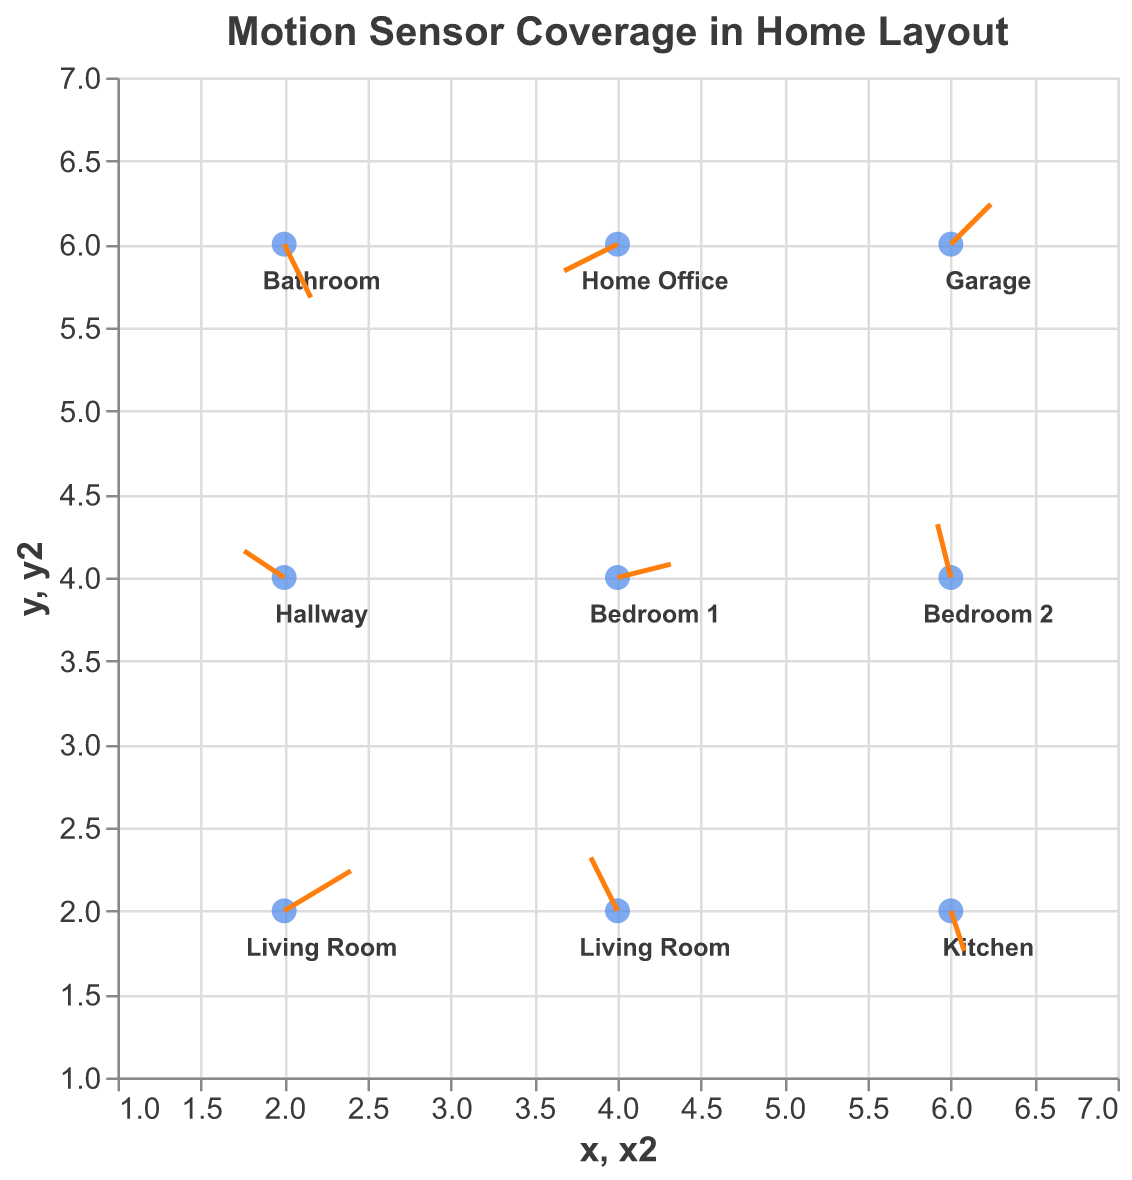What's the title of the figure? The title is usually found at the top of the figure. Here, it is written in a bold font to make it stand out.
Answer: Motion Sensor Coverage in Home Layout How many locations are shown in the figure? To find the number of locations, count the unique points labeled with location names in the plot.
Answer: 9 Which location has a motion vector pointing directly upwards? Look at the direction of the vectors (arrows). An upward vector means a positive value in the v component. The location with (u, v) as (-0.2, 0.4) fits this description.
Answer: Living Room (at x=4, y=2) Which location has the longest vector and what is its direction? To identify the longest vector, calculate the magnitude of each vector using sqrt(u^2 + v^2). The vector at x=2, y=2 has (u, v) as (0.5, 0.3). The magnitude is sqrt(0.5^2 + 0.3^2) = 0.583. No other vector exceeds this magnitude. Direction can be seen from the unit components (right and slightly upwards).
Answer: Living Room (x=2, y=2), right and upwards What’s the location of the vector closest to (5, 5)? To find the closest point, locate the data point nearest to (5, 5). Check the coordinates of each point. The point at (4, 4) is closest to (5, 5).
Answer: Bedroom 1 Which rooms have vectors pointing out of the origin of their placement? Look for vectors where both u and v components are positive. The locations with positive components are those pointing away from their point of origin.
Answer: Living Room (x=2, y=2), Bedroom 1, Garage What is the average x-coordinate of Living Room points? The x-coordinates of the Living Room are 2 and 4. Therefore, (2+4)/2 = 3.
Answer: 3 Compare the direction of the vectors in the Home Office and Kitchen. Which one points more downward? Check the 'v' values for these locations. Kitchen has v as -0.3 and Home Office has v as -0.2. A more negative value means it points more downward.
Answer: Kitchen What can you infer about motion coverage in the Garage from its vector? The Garage’s vector (0.3, 0.3) suggests motion detection is active and pointing diagonally upwards and to the right, indicating good coverage in that direction.
Answer: Active, diagonally upwards and right Which location likely has the least coverage based on vector length? The shortest vector would indicate the weakest coverage. Compute the magnitude of motion vector for all points. The smallest magnitude is at x=6, y=4, with coordinates (-0.1, 0.4) yielding sqrt((-0.1)^2 + 0.4^2) = 0.412.
Answer: Bedroom 2 